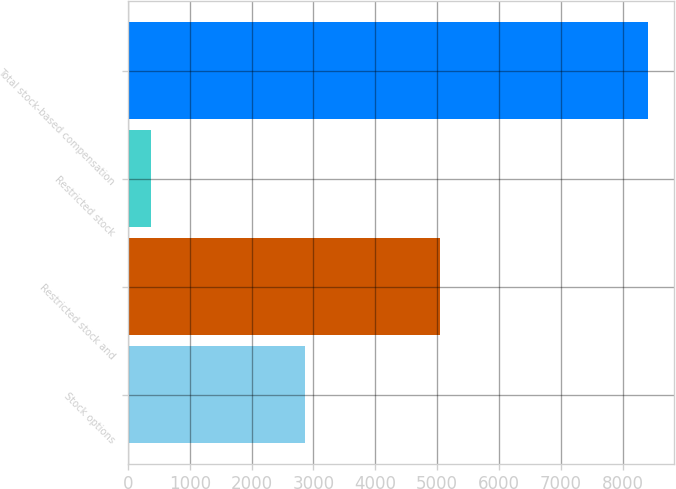Convert chart to OTSL. <chart><loc_0><loc_0><loc_500><loc_500><bar_chart><fcel>Stock options<fcel>Restricted stock and<fcel>Restricted stock<fcel>Total stock-based compensation<nl><fcel>2858<fcel>5040<fcel>373<fcel>8414<nl></chart> 